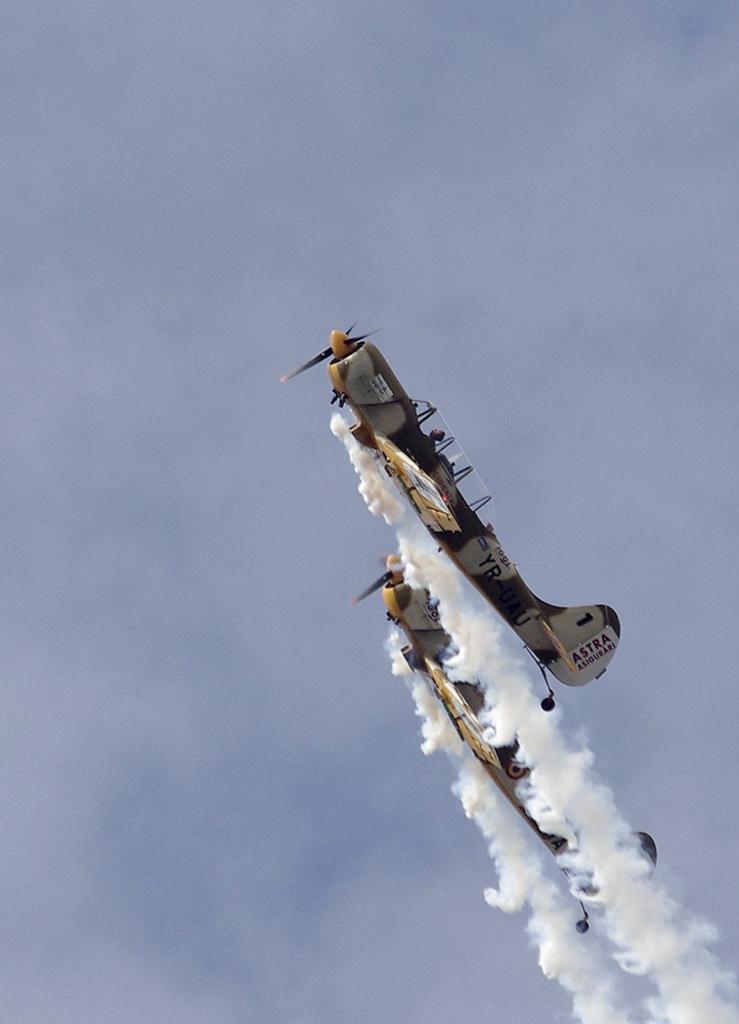Describe this image in one or two sentences. In this image, at the right side there are two aeroplane flying and there is smoke releasing from the aeroplanes which is in white color, at the background there is a sky. 